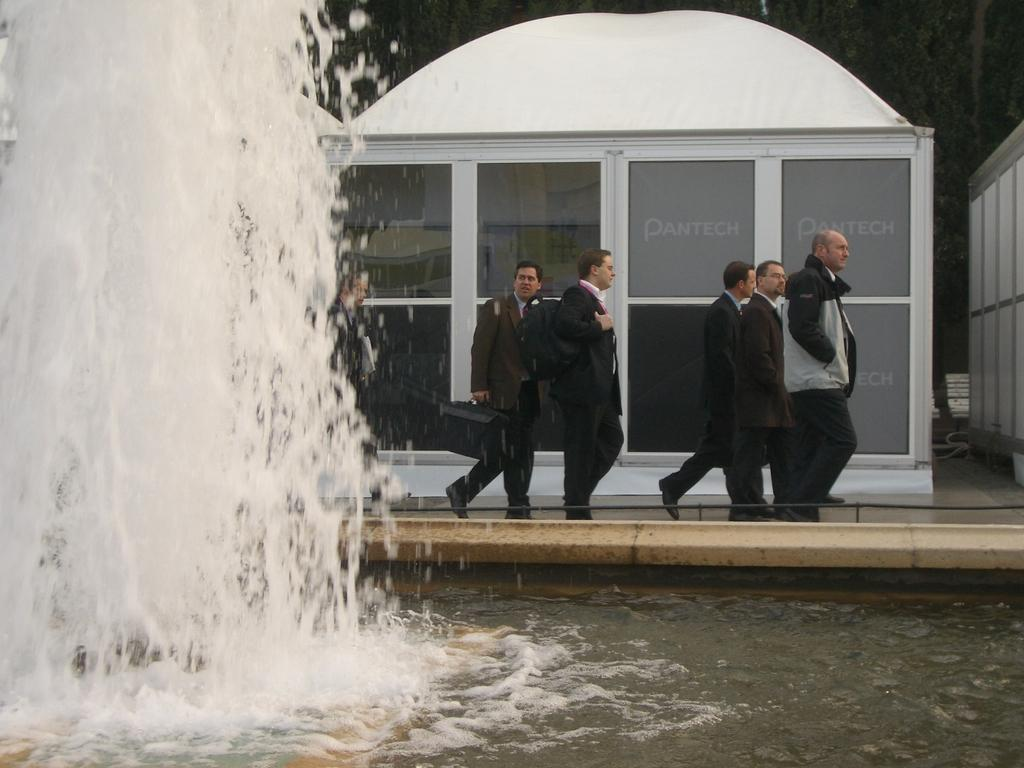What can be seen in the image that is related to water? There is water visible in the image. What type of objects are present in the image? There are bags and other objects in the image. What type of structure can be seen in the image? There is a shed in the image. What type of architectural feature is present in the image? There is a wall in the image. What type of living organisms can be seen in the image? There are people on the ground in the image. What can be seen in the background of the image? There are trees in the background of the image. What type of wine is being served in the image? There is no wine present in the image. What type of game are the people playing in the image? There is no game being played in the image; the people are simply standing on the ground. 